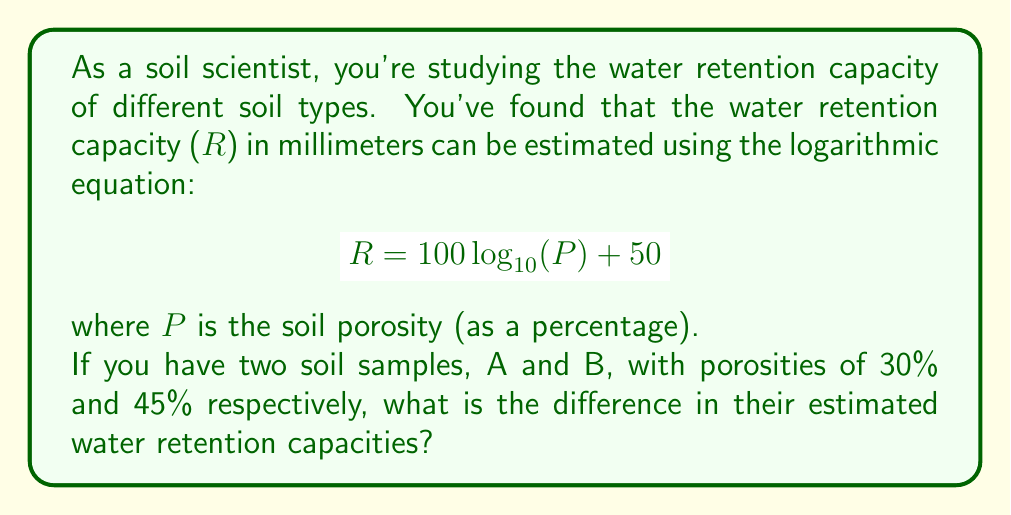Can you answer this question? To solve this problem, we need to calculate the water retention capacity for each soil sample and then find the difference between them.

1. For Soil A (30% porosity):
   $$R_A = 100 \log_{10}(30) + 50$$
   $$R_A = 100 \cdot 1.4771 + 50$$
   $$R_A = 147.71 + 50 = 197.71 \text{ mm}$$

2. For Soil B (45% porosity):
   $$R_B = 100 \log_{10}(45) + 50$$
   $$R_B = 100 \cdot 1.6532 + 50$$
   $$R_B = 165.32 + 50 = 215.32 \text{ mm}$$

3. Calculate the difference:
   $$\text{Difference} = R_B - R_A$$
   $$\text{Difference} = 215.32 - 197.71 = 17.61 \text{ mm}$$

Therefore, the difference in estimated water retention capacities between Soil B and Soil A is approximately 17.61 mm.
Answer: The difference in estimated water retention capacities between the two soil samples is approximately 17.61 mm. 